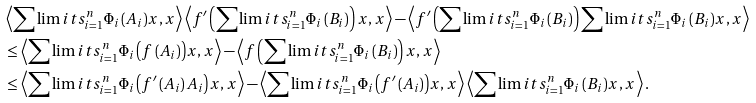<formula> <loc_0><loc_0><loc_500><loc_500>& \left \langle \sum \lim i t s _ { i = 1 } ^ { n } { { { \Phi } _ { i } } \left ( { { A } _ { i } } \right ) } x , x \right \rangle \left \langle f ^ { \prime } \left ( \sum \lim i t s _ { i = 1 } ^ { n } { { { \Phi } _ { i } } \left ( { { B } _ { i } } \right ) } \right ) x , x \right \rangle - \left \langle f ^ { \prime } \left ( \sum \lim i t s _ { i = 1 } ^ { n } { { { \Phi } _ { i } } \left ( { { B } _ { i } } \right ) } \right ) \sum \lim i t s _ { i = 1 } ^ { n } { { { \Phi } _ { i } } \left ( { { B } _ { i } } \right ) } x , x \right \rangle \\ & \leq \left \langle \sum \lim i t s _ { i = 1 } ^ { n } { { { \Phi } _ { i } } \left ( f \left ( { { A } _ { i } } \right ) \right ) } x , x \right \rangle - \left \langle f \left ( \sum \lim i t s _ { i = 1 } ^ { n } { { { \Phi } _ { i } } \left ( { { B } _ { i } } \right ) } \right ) x , x \right \rangle \\ & \leq \left \langle \sum \lim i t s _ { i = 1 } ^ { n } { { { \Phi } _ { i } } \left ( f ^ { \prime } \left ( { { A } _ { i } } \right ) { { A } _ { i } } \right ) } x , x \right \rangle - \left \langle \sum \lim i t s _ { i = 1 } ^ { n } { { { \Phi } _ { i } } \left ( f ^ { \prime } \left ( { { A } _ { i } } \right ) \right ) } x , x \right \rangle \left \langle \sum \lim i t s _ { i = 1 } ^ { n } { { { \Phi } _ { i } } \left ( { { B } _ { i } } \right ) } x , x \right \rangle .</formula> 